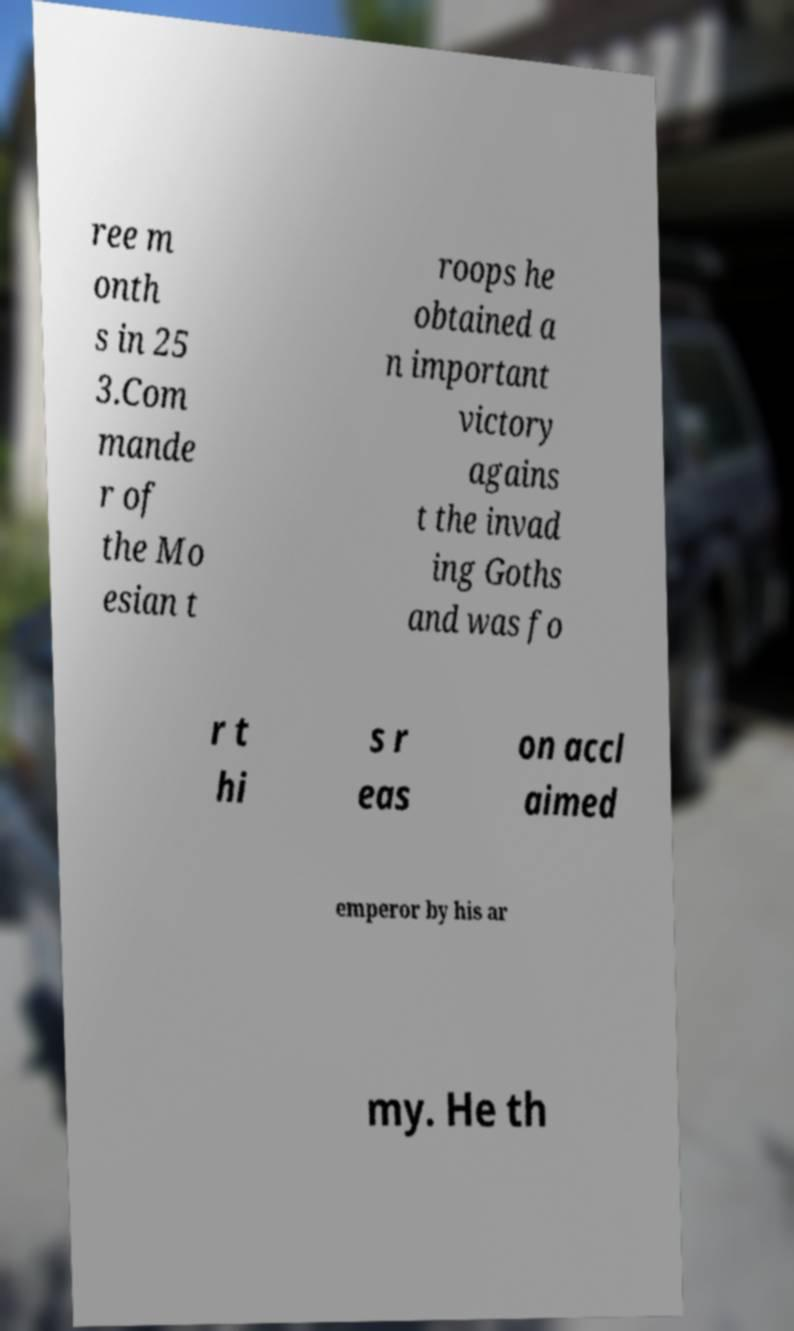Please read and relay the text visible in this image. What does it say? ree m onth s in 25 3.Com mande r of the Mo esian t roops he obtained a n important victory agains t the invad ing Goths and was fo r t hi s r eas on accl aimed emperor by his ar my. He th 